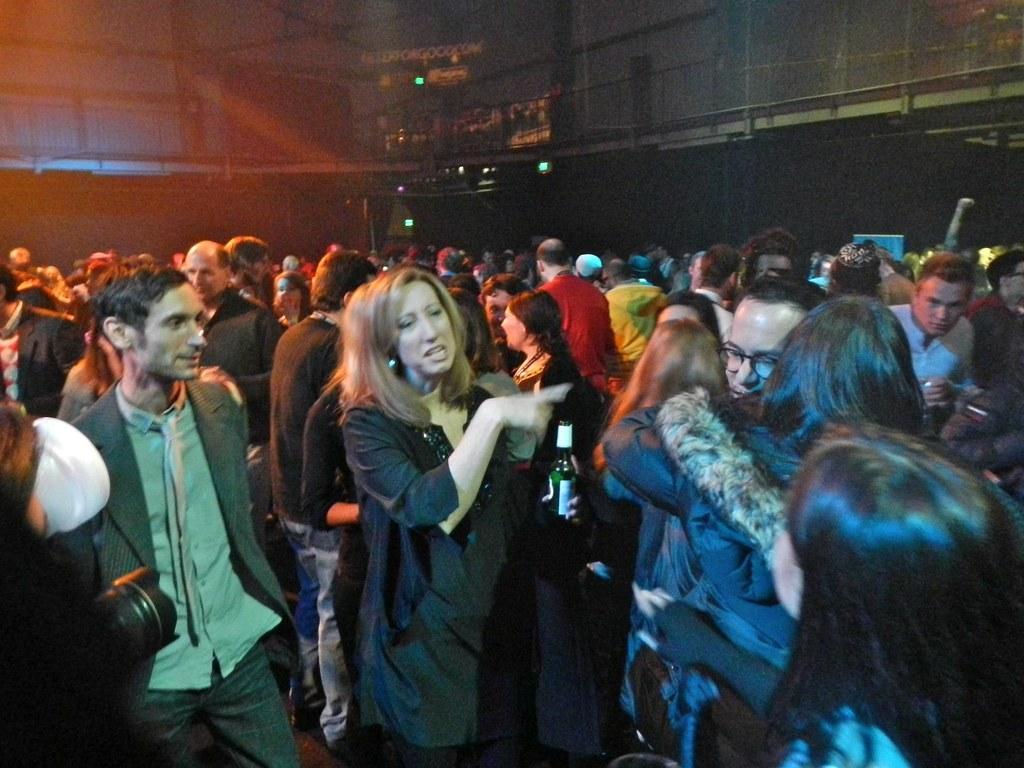Can you describe this image briefly? In this image I can see a crowd on the floor. In the background I can see a building and fence. This image is taken during night. 